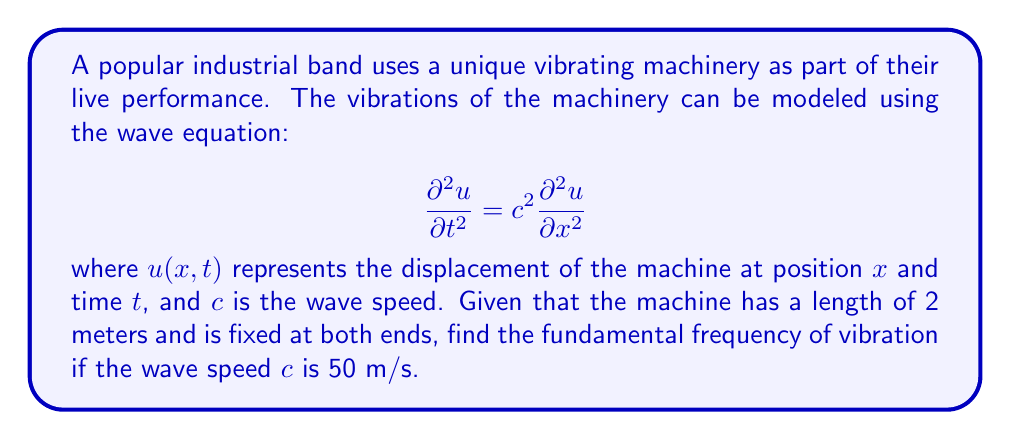Help me with this question. To solve this problem, we'll follow these steps:

1) For a string (or in this case, a vibrating machine) fixed at both ends, the general solution to the wave equation is:

   $$u(x,t) = \sum_{n=1}^{\infty} A_n \sin(\frac{n\pi x}{L}) \cos(\frac{n\pi c t}{L})$$

   where $L$ is the length of the string (or machine).

2) The fundamental frequency corresponds to $n=1$. The frequency $f$ is related to the angular frequency $\omega$ by:

   $$f = \frac{\omega}{2\pi}$$

3) From the cosine term in the general solution, we can see that:

   $$\omega = \frac{\pi c}{L}$$

4) Substituting this into the frequency equation:

   $$f = \frac{c}{2L}$$

5) We're given that $c = 50$ m/s and $L = 2$ m. Let's substitute these values:

   $$f = \frac{50}{2(2)} = \frac{50}{4} = 12.5$$

Therefore, the fundamental frequency is 12.5 Hz.
Answer: 12.5 Hz 